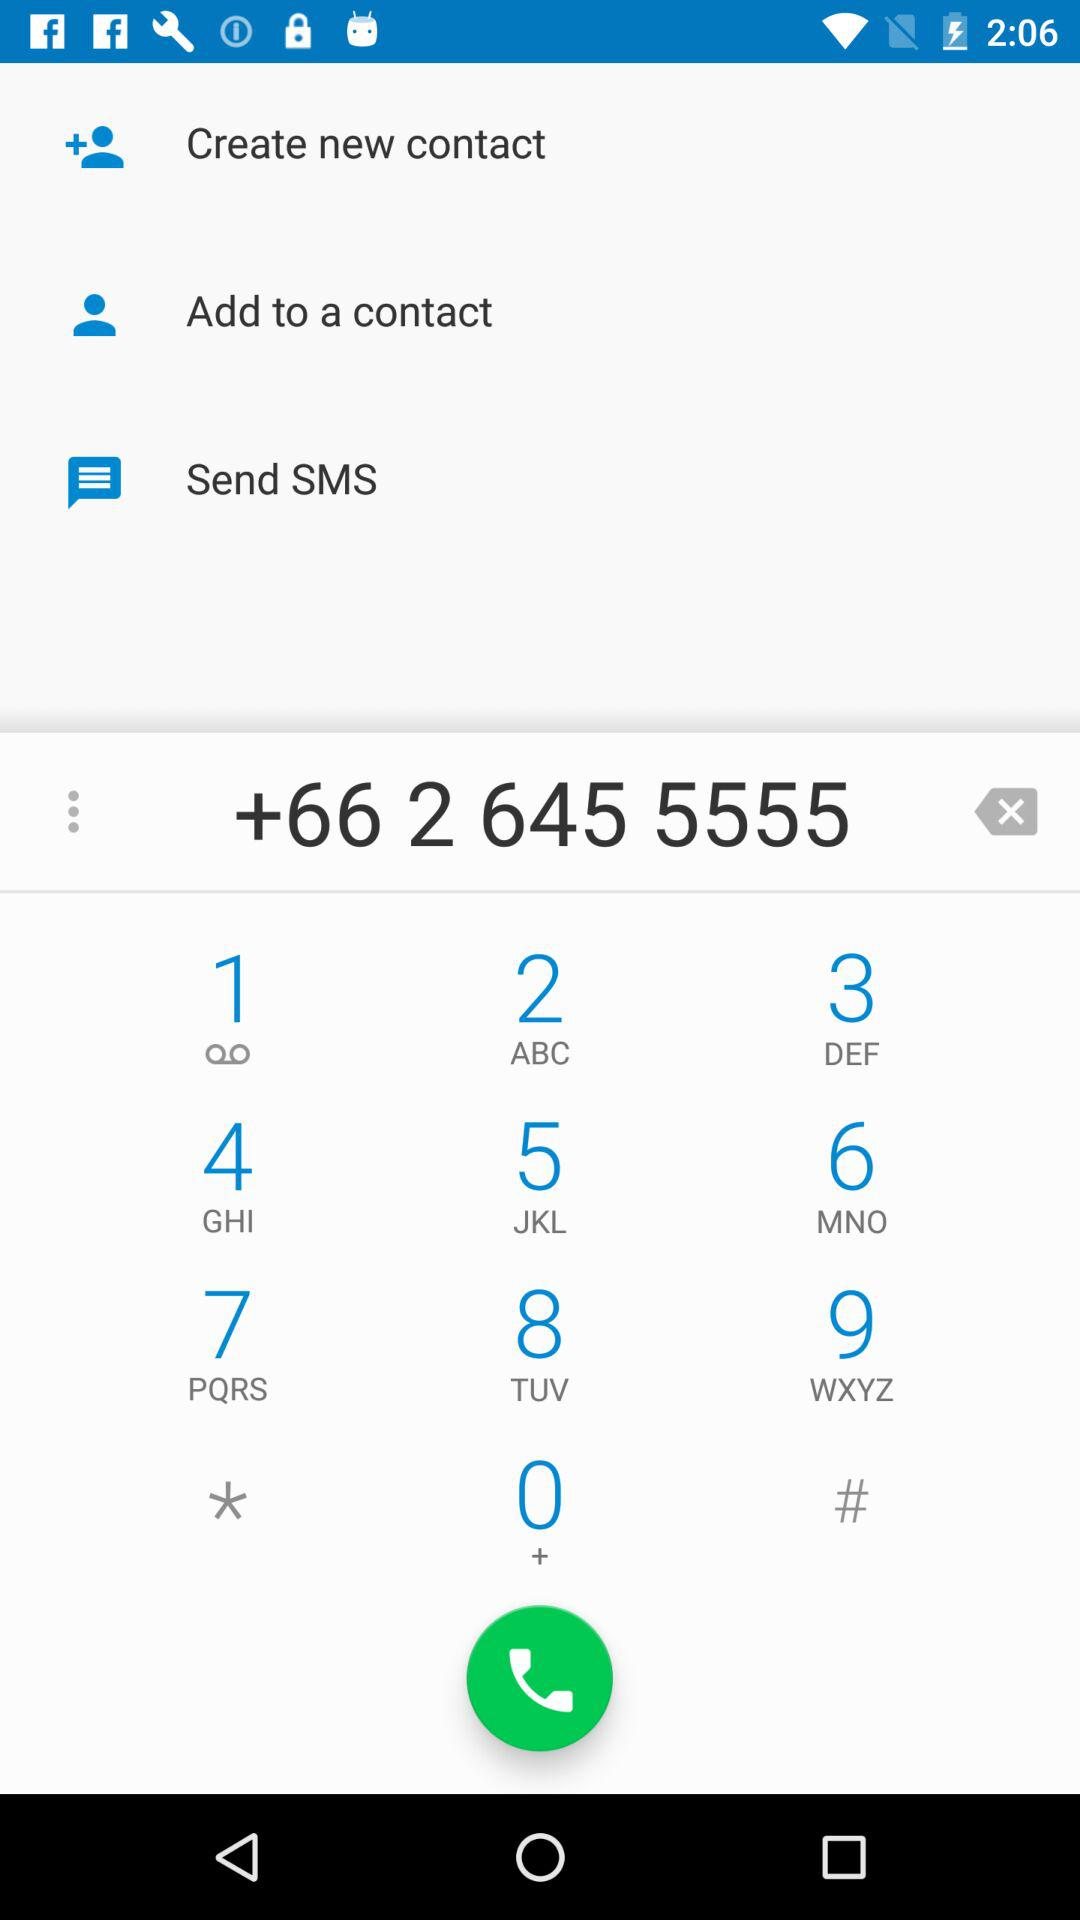What is the contact number? The contact number is +66 2 645 5555. 